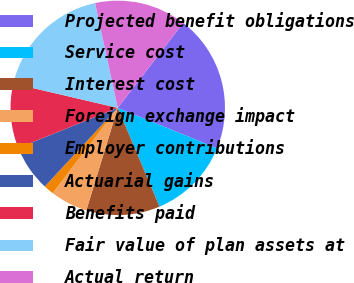Convert chart to OTSL. <chart><loc_0><loc_0><loc_500><loc_500><pie_chart><fcel>Projected benefit obligations<fcel>Service cost<fcel>Interest cost<fcel>Foreign exchange impact<fcel>Employer contributions<fcel>Actuarial gains<fcel>Benefits paid<fcel>Fair value of plan assets at<fcel>Actual return<nl><fcel>20.69%<fcel>12.48%<fcel>11.11%<fcel>5.64%<fcel>1.53%<fcel>7.0%<fcel>9.74%<fcel>17.96%<fcel>13.85%<nl></chart> 